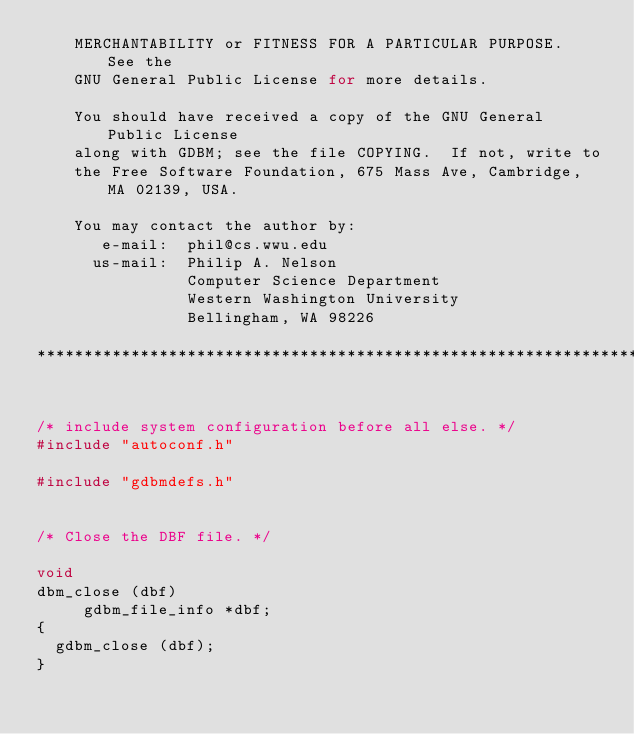Convert code to text. <code><loc_0><loc_0><loc_500><loc_500><_C_>    MERCHANTABILITY or FITNESS FOR A PARTICULAR PURPOSE.  See the
    GNU General Public License for more details.

    You should have received a copy of the GNU General Public License
    along with GDBM; see the file COPYING.  If not, write to
    the Free Software Foundation, 675 Mass Ave, Cambridge, MA 02139, USA.

    You may contact the author by:
       e-mail:  phil@cs.wwu.edu
      us-mail:  Philip A. Nelson
                Computer Science Department
                Western Washington University
                Bellingham, WA 98226
       
*************************************************************************/


/* include system configuration before all else. */
#include "autoconf.h"

#include "gdbmdefs.h"


/* Close the DBF file. */

void
dbm_close (dbf)
     gdbm_file_info *dbf;
{
  gdbm_close (dbf);
}
</code> 